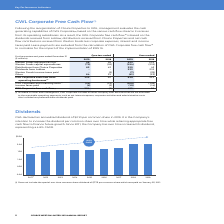According to George Weston Limited's financial document, What is the basis for evaluation of cash generating capabilities of GWL? based on the various cash flow streams it receives from its operating subsidiaries.. The document states: "cash generating capabilities of GWL Corporate (2) based on the various cash flow streams it receives from its operating subsidiaries. As a result, the..." Also, What is the GWL Corporate free cash flow based on? based on the dividends received from Loblaw, distributions received from Choice Properties and net cash flow contributions received from Weston Foods less corporate expenses, interest and income taxes paid. The document states: "a result, the GWL Corporate free cash flow (1) is based on the dividends received from Loblaw, distributions received from Choice Properties and net c..." Also, What additional items are included in Other and Intersegment of GWL Corporate? includes all other company level activities that are not allocated to the reportable operating segments, such as net interest expense, corporate activities and administrative costs. Also included are preferred share dividends paid.. The document states: "Included in Other and Intersegment, GWL Corporate includes all other company level activities that are not allocated to the reportable operating segme..." Also, can you calculate: What is the increase / (decrease) in the Weston Foods adjusted EBITDA from 2018 to 2019? Based on the calculation: 56 - 59, the result is -3 (in millions). This is based on the information: "Weston Foods adjusted EBITDA (1) 56 59 223 233 Weston Foods capital expenditures (70) (91) (194) (212) Distributions from Choice Proper Weston Foods adjusted EBITDA (1) 56 59 223 233 Weston Foods capi..." The key data points involved are: 56, 59. Also, can you calculate: What is the average Distributions from Choice Properties for quarters ended in 2019 and 2018? To answer this question, I need to perform calculations using the financial data. The calculation is: (82 + 43) / 2, which equals 62.5 (in millions). This is based on the information: "94) (212) Distributions from Choice Properties 82 43 325 43 Dividends from Loblaw – – 233 212 Weston Foods income taxes paid – (2) (7) (32) Other 64 21 (194) (212) Distributions from Choice Properties..." The key data points involved are: 43, 82. Also, can you calculate: What is the percentage increase in the GWL Corporate cash flow from operating businesses for quarters ended 2018 to 2019? To answer this question, I need to perform calculations using the financial data. The calculation is: 132 / 30 - 1, which equals 340 (percentage). This is based on the information: "orate cash flow from operating businesses (1) 132 30 539 221 Corporate cash flow from operating businesses (1) 132 30 539 221..." The key data points involved are: 132, 30. 